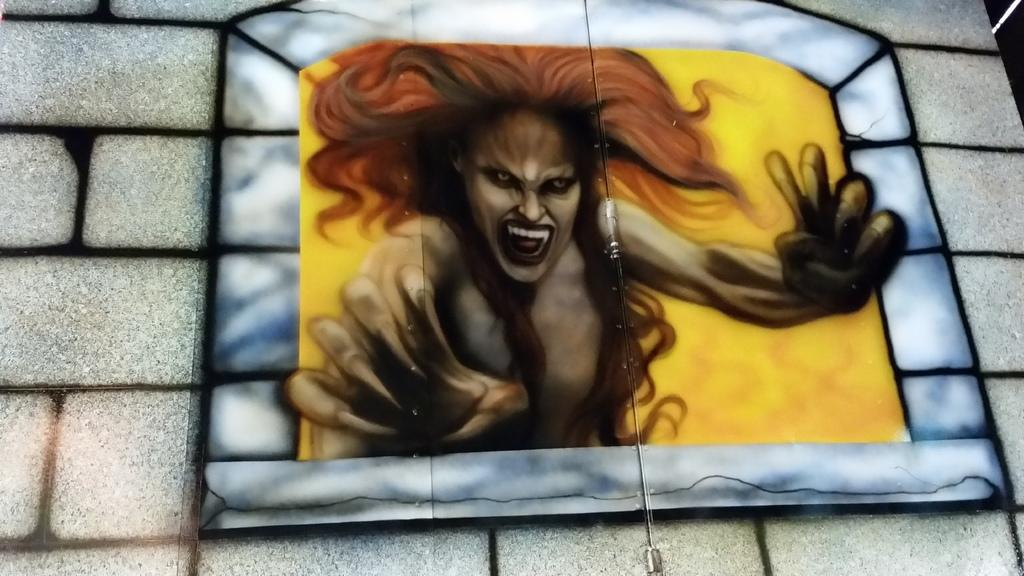Where was the image taken? The image is taken outdoors. What structure can be seen in the image? There is a wall in the image. What is depicted on the wall in the image? There is a painting of a ghost on the wall. What type of waves can be seen crashing against the mountain in the image? There is no mountain or waves present in the image; it features a wall with a painting of a ghost. 